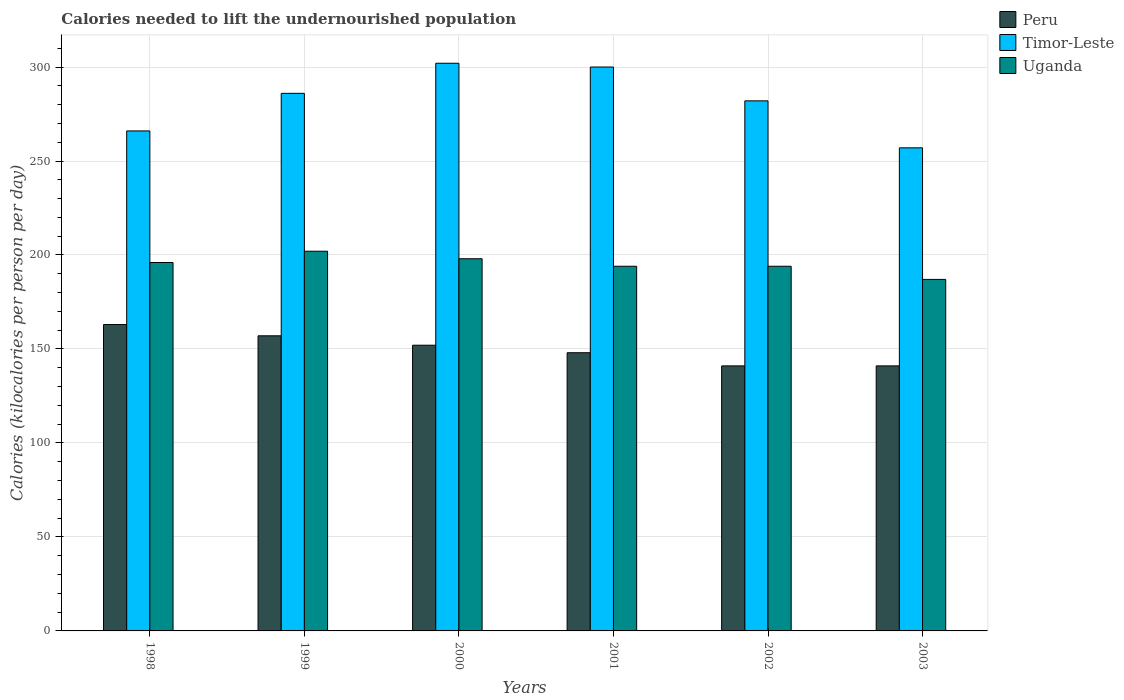Are the number of bars on each tick of the X-axis equal?
Offer a very short reply. Yes. How many bars are there on the 2nd tick from the left?
Ensure brevity in your answer.  3. How many bars are there on the 6th tick from the right?
Your response must be concise. 3. In how many cases, is the number of bars for a given year not equal to the number of legend labels?
Provide a short and direct response. 0. What is the total calories needed to lift the undernourished population in Uganda in 1998?
Make the answer very short. 196. Across all years, what is the maximum total calories needed to lift the undernourished population in Peru?
Offer a very short reply. 163. Across all years, what is the minimum total calories needed to lift the undernourished population in Uganda?
Provide a succinct answer. 187. In which year was the total calories needed to lift the undernourished population in Uganda maximum?
Give a very brief answer. 1999. In which year was the total calories needed to lift the undernourished population in Timor-Leste minimum?
Your answer should be very brief. 2003. What is the total total calories needed to lift the undernourished population in Timor-Leste in the graph?
Ensure brevity in your answer.  1693. What is the difference between the total calories needed to lift the undernourished population in Uganda in 2000 and that in 2003?
Your answer should be very brief. 11. What is the difference between the total calories needed to lift the undernourished population in Peru in 2003 and the total calories needed to lift the undernourished population in Timor-Leste in 2001?
Provide a succinct answer. -159. What is the average total calories needed to lift the undernourished population in Timor-Leste per year?
Your answer should be compact. 282.17. In the year 2002, what is the difference between the total calories needed to lift the undernourished population in Uganda and total calories needed to lift the undernourished population in Timor-Leste?
Your answer should be very brief. -88. In how many years, is the total calories needed to lift the undernourished population in Uganda greater than 20 kilocalories?
Give a very brief answer. 6. What is the ratio of the total calories needed to lift the undernourished population in Timor-Leste in 1999 to that in 2001?
Your response must be concise. 0.95. What is the difference between the highest and the lowest total calories needed to lift the undernourished population in Uganda?
Your answer should be compact. 15. What does the 2nd bar from the left in 1998 represents?
Your answer should be compact. Timor-Leste. How many bars are there?
Offer a very short reply. 18. What is the difference between two consecutive major ticks on the Y-axis?
Give a very brief answer. 50. Does the graph contain any zero values?
Give a very brief answer. No. Does the graph contain grids?
Keep it short and to the point. Yes. How many legend labels are there?
Keep it short and to the point. 3. What is the title of the graph?
Your answer should be compact. Calories needed to lift the undernourished population. What is the label or title of the Y-axis?
Make the answer very short. Calories (kilocalories per person per day). What is the Calories (kilocalories per person per day) in Peru in 1998?
Keep it short and to the point. 163. What is the Calories (kilocalories per person per day) in Timor-Leste in 1998?
Offer a very short reply. 266. What is the Calories (kilocalories per person per day) of Uganda in 1998?
Your response must be concise. 196. What is the Calories (kilocalories per person per day) of Peru in 1999?
Your answer should be compact. 157. What is the Calories (kilocalories per person per day) of Timor-Leste in 1999?
Give a very brief answer. 286. What is the Calories (kilocalories per person per day) of Uganda in 1999?
Make the answer very short. 202. What is the Calories (kilocalories per person per day) in Peru in 2000?
Provide a succinct answer. 152. What is the Calories (kilocalories per person per day) in Timor-Leste in 2000?
Offer a very short reply. 302. What is the Calories (kilocalories per person per day) of Uganda in 2000?
Ensure brevity in your answer.  198. What is the Calories (kilocalories per person per day) in Peru in 2001?
Offer a very short reply. 148. What is the Calories (kilocalories per person per day) in Timor-Leste in 2001?
Provide a short and direct response. 300. What is the Calories (kilocalories per person per day) of Uganda in 2001?
Provide a succinct answer. 194. What is the Calories (kilocalories per person per day) of Peru in 2002?
Provide a short and direct response. 141. What is the Calories (kilocalories per person per day) in Timor-Leste in 2002?
Keep it short and to the point. 282. What is the Calories (kilocalories per person per day) in Uganda in 2002?
Keep it short and to the point. 194. What is the Calories (kilocalories per person per day) in Peru in 2003?
Make the answer very short. 141. What is the Calories (kilocalories per person per day) of Timor-Leste in 2003?
Offer a terse response. 257. What is the Calories (kilocalories per person per day) of Uganda in 2003?
Offer a terse response. 187. Across all years, what is the maximum Calories (kilocalories per person per day) in Peru?
Offer a terse response. 163. Across all years, what is the maximum Calories (kilocalories per person per day) in Timor-Leste?
Make the answer very short. 302. Across all years, what is the maximum Calories (kilocalories per person per day) of Uganda?
Offer a very short reply. 202. Across all years, what is the minimum Calories (kilocalories per person per day) in Peru?
Ensure brevity in your answer.  141. Across all years, what is the minimum Calories (kilocalories per person per day) of Timor-Leste?
Your answer should be compact. 257. Across all years, what is the minimum Calories (kilocalories per person per day) of Uganda?
Provide a succinct answer. 187. What is the total Calories (kilocalories per person per day) in Peru in the graph?
Keep it short and to the point. 902. What is the total Calories (kilocalories per person per day) in Timor-Leste in the graph?
Provide a short and direct response. 1693. What is the total Calories (kilocalories per person per day) of Uganda in the graph?
Keep it short and to the point. 1171. What is the difference between the Calories (kilocalories per person per day) of Peru in 1998 and that in 1999?
Offer a very short reply. 6. What is the difference between the Calories (kilocalories per person per day) in Uganda in 1998 and that in 1999?
Offer a terse response. -6. What is the difference between the Calories (kilocalories per person per day) in Peru in 1998 and that in 2000?
Keep it short and to the point. 11. What is the difference between the Calories (kilocalories per person per day) of Timor-Leste in 1998 and that in 2000?
Offer a very short reply. -36. What is the difference between the Calories (kilocalories per person per day) in Timor-Leste in 1998 and that in 2001?
Your answer should be compact. -34. What is the difference between the Calories (kilocalories per person per day) in Uganda in 1998 and that in 2001?
Keep it short and to the point. 2. What is the difference between the Calories (kilocalories per person per day) of Uganda in 1998 and that in 2002?
Your answer should be very brief. 2. What is the difference between the Calories (kilocalories per person per day) of Timor-Leste in 1998 and that in 2003?
Provide a succinct answer. 9. What is the difference between the Calories (kilocalories per person per day) in Peru in 1999 and that in 2000?
Give a very brief answer. 5. What is the difference between the Calories (kilocalories per person per day) in Timor-Leste in 1999 and that in 2000?
Offer a very short reply. -16. What is the difference between the Calories (kilocalories per person per day) in Uganda in 1999 and that in 2000?
Your response must be concise. 4. What is the difference between the Calories (kilocalories per person per day) in Peru in 1999 and that in 2001?
Your response must be concise. 9. What is the difference between the Calories (kilocalories per person per day) of Timor-Leste in 1999 and that in 2001?
Provide a succinct answer. -14. What is the difference between the Calories (kilocalories per person per day) in Uganda in 1999 and that in 2001?
Offer a terse response. 8. What is the difference between the Calories (kilocalories per person per day) of Peru in 1999 and that in 2002?
Provide a short and direct response. 16. What is the difference between the Calories (kilocalories per person per day) in Timor-Leste in 1999 and that in 2002?
Give a very brief answer. 4. What is the difference between the Calories (kilocalories per person per day) in Timor-Leste in 1999 and that in 2003?
Make the answer very short. 29. What is the difference between the Calories (kilocalories per person per day) in Uganda in 1999 and that in 2003?
Offer a terse response. 15. What is the difference between the Calories (kilocalories per person per day) of Timor-Leste in 2000 and that in 2001?
Ensure brevity in your answer.  2. What is the difference between the Calories (kilocalories per person per day) in Uganda in 2000 and that in 2001?
Ensure brevity in your answer.  4. What is the difference between the Calories (kilocalories per person per day) of Peru in 2000 and that in 2002?
Your response must be concise. 11. What is the difference between the Calories (kilocalories per person per day) of Timor-Leste in 2000 and that in 2003?
Your answer should be very brief. 45. What is the difference between the Calories (kilocalories per person per day) in Peru in 2001 and that in 2002?
Your answer should be compact. 7. What is the difference between the Calories (kilocalories per person per day) of Timor-Leste in 2001 and that in 2002?
Your answer should be very brief. 18. What is the difference between the Calories (kilocalories per person per day) in Uganda in 2001 and that in 2002?
Make the answer very short. 0. What is the difference between the Calories (kilocalories per person per day) in Timor-Leste in 2001 and that in 2003?
Offer a very short reply. 43. What is the difference between the Calories (kilocalories per person per day) in Uganda in 2001 and that in 2003?
Ensure brevity in your answer.  7. What is the difference between the Calories (kilocalories per person per day) of Peru in 1998 and the Calories (kilocalories per person per day) of Timor-Leste in 1999?
Give a very brief answer. -123. What is the difference between the Calories (kilocalories per person per day) in Peru in 1998 and the Calories (kilocalories per person per day) in Uganda in 1999?
Give a very brief answer. -39. What is the difference between the Calories (kilocalories per person per day) in Timor-Leste in 1998 and the Calories (kilocalories per person per day) in Uganda in 1999?
Provide a short and direct response. 64. What is the difference between the Calories (kilocalories per person per day) in Peru in 1998 and the Calories (kilocalories per person per day) in Timor-Leste in 2000?
Keep it short and to the point. -139. What is the difference between the Calories (kilocalories per person per day) of Peru in 1998 and the Calories (kilocalories per person per day) of Uganda in 2000?
Offer a terse response. -35. What is the difference between the Calories (kilocalories per person per day) of Peru in 1998 and the Calories (kilocalories per person per day) of Timor-Leste in 2001?
Ensure brevity in your answer.  -137. What is the difference between the Calories (kilocalories per person per day) of Peru in 1998 and the Calories (kilocalories per person per day) of Uganda in 2001?
Provide a succinct answer. -31. What is the difference between the Calories (kilocalories per person per day) in Timor-Leste in 1998 and the Calories (kilocalories per person per day) in Uganda in 2001?
Keep it short and to the point. 72. What is the difference between the Calories (kilocalories per person per day) in Peru in 1998 and the Calories (kilocalories per person per day) in Timor-Leste in 2002?
Make the answer very short. -119. What is the difference between the Calories (kilocalories per person per day) of Peru in 1998 and the Calories (kilocalories per person per day) of Uganda in 2002?
Offer a very short reply. -31. What is the difference between the Calories (kilocalories per person per day) in Timor-Leste in 1998 and the Calories (kilocalories per person per day) in Uganda in 2002?
Provide a succinct answer. 72. What is the difference between the Calories (kilocalories per person per day) of Peru in 1998 and the Calories (kilocalories per person per day) of Timor-Leste in 2003?
Ensure brevity in your answer.  -94. What is the difference between the Calories (kilocalories per person per day) of Timor-Leste in 1998 and the Calories (kilocalories per person per day) of Uganda in 2003?
Provide a succinct answer. 79. What is the difference between the Calories (kilocalories per person per day) in Peru in 1999 and the Calories (kilocalories per person per day) in Timor-Leste in 2000?
Your answer should be very brief. -145. What is the difference between the Calories (kilocalories per person per day) in Peru in 1999 and the Calories (kilocalories per person per day) in Uganda in 2000?
Make the answer very short. -41. What is the difference between the Calories (kilocalories per person per day) of Peru in 1999 and the Calories (kilocalories per person per day) of Timor-Leste in 2001?
Provide a short and direct response. -143. What is the difference between the Calories (kilocalories per person per day) in Peru in 1999 and the Calories (kilocalories per person per day) in Uganda in 2001?
Your answer should be compact. -37. What is the difference between the Calories (kilocalories per person per day) of Timor-Leste in 1999 and the Calories (kilocalories per person per day) of Uganda in 2001?
Give a very brief answer. 92. What is the difference between the Calories (kilocalories per person per day) of Peru in 1999 and the Calories (kilocalories per person per day) of Timor-Leste in 2002?
Provide a short and direct response. -125. What is the difference between the Calories (kilocalories per person per day) in Peru in 1999 and the Calories (kilocalories per person per day) in Uganda in 2002?
Give a very brief answer. -37. What is the difference between the Calories (kilocalories per person per day) in Timor-Leste in 1999 and the Calories (kilocalories per person per day) in Uganda in 2002?
Your answer should be very brief. 92. What is the difference between the Calories (kilocalories per person per day) of Peru in 1999 and the Calories (kilocalories per person per day) of Timor-Leste in 2003?
Your answer should be very brief. -100. What is the difference between the Calories (kilocalories per person per day) in Peru in 1999 and the Calories (kilocalories per person per day) in Uganda in 2003?
Give a very brief answer. -30. What is the difference between the Calories (kilocalories per person per day) in Timor-Leste in 1999 and the Calories (kilocalories per person per day) in Uganda in 2003?
Ensure brevity in your answer.  99. What is the difference between the Calories (kilocalories per person per day) of Peru in 2000 and the Calories (kilocalories per person per day) of Timor-Leste in 2001?
Ensure brevity in your answer.  -148. What is the difference between the Calories (kilocalories per person per day) in Peru in 2000 and the Calories (kilocalories per person per day) in Uganda in 2001?
Keep it short and to the point. -42. What is the difference between the Calories (kilocalories per person per day) of Timor-Leste in 2000 and the Calories (kilocalories per person per day) of Uganda in 2001?
Your response must be concise. 108. What is the difference between the Calories (kilocalories per person per day) in Peru in 2000 and the Calories (kilocalories per person per day) in Timor-Leste in 2002?
Offer a terse response. -130. What is the difference between the Calories (kilocalories per person per day) in Peru in 2000 and the Calories (kilocalories per person per day) in Uganda in 2002?
Provide a short and direct response. -42. What is the difference between the Calories (kilocalories per person per day) of Timor-Leste in 2000 and the Calories (kilocalories per person per day) of Uganda in 2002?
Make the answer very short. 108. What is the difference between the Calories (kilocalories per person per day) in Peru in 2000 and the Calories (kilocalories per person per day) in Timor-Leste in 2003?
Give a very brief answer. -105. What is the difference between the Calories (kilocalories per person per day) in Peru in 2000 and the Calories (kilocalories per person per day) in Uganda in 2003?
Provide a succinct answer. -35. What is the difference between the Calories (kilocalories per person per day) of Timor-Leste in 2000 and the Calories (kilocalories per person per day) of Uganda in 2003?
Make the answer very short. 115. What is the difference between the Calories (kilocalories per person per day) of Peru in 2001 and the Calories (kilocalories per person per day) of Timor-Leste in 2002?
Your answer should be very brief. -134. What is the difference between the Calories (kilocalories per person per day) of Peru in 2001 and the Calories (kilocalories per person per day) of Uganda in 2002?
Your answer should be compact. -46. What is the difference between the Calories (kilocalories per person per day) of Timor-Leste in 2001 and the Calories (kilocalories per person per day) of Uganda in 2002?
Keep it short and to the point. 106. What is the difference between the Calories (kilocalories per person per day) of Peru in 2001 and the Calories (kilocalories per person per day) of Timor-Leste in 2003?
Ensure brevity in your answer.  -109. What is the difference between the Calories (kilocalories per person per day) in Peru in 2001 and the Calories (kilocalories per person per day) in Uganda in 2003?
Make the answer very short. -39. What is the difference between the Calories (kilocalories per person per day) in Timor-Leste in 2001 and the Calories (kilocalories per person per day) in Uganda in 2003?
Ensure brevity in your answer.  113. What is the difference between the Calories (kilocalories per person per day) in Peru in 2002 and the Calories (kilocalories per person per day) in Timor-Leste in 2003?
Give a very brief answer. -116. What is the difference between the Calories (kilocalories per person per day) in Peru in 2002 and the Calories (kilocalories per person per day) in Uganda in 2003?
Your answer should be very brief. -46. What is the average Calories (kilocalories per person per day) in Peru per year?
Offer a very short reply. 150.33. What is the average Calories (kilocalories per person per day) of Timor-Leste per year?
Provide a short and direct response. 282.17. What is the average Calories (kilocalories per person per day) of Uganda per year?
Ensure brevity in your answer.  195.17. In the year 1998, what is the difference between the Calories (kilocalories per person per day) in Peru and Calories (kilocalories per person per day) in Timor-Leste?
Your response must be concise. -103. In the year 1998, what is the difference between the Calories (kilocalories per person per day) in Peru and Calories (kilocalories per person per day) in Uganda?
Provide a short and direct response. -33. In the year 1998, what is the difference between the Calories (kilocalories per person per day) in Timor-Leste and Calories (kilocalories per person per day) in Uganda?
Offer a terse response. 70. In the year 1999, what is the difference between the Calories (kilocalories per person per day) of Peru and Calories (kilocalories per person per day) of Timor-Leste?
Keep it short and to the point. -129. In the year 1999, what is the difference between the Calories (kilocalories per person per day) of Peru and Calories (kilocalories per person per day) of Uganda?
Ensure brevity in your answer.  -45. In the year 2000, what is the difference between the Calories (kilocalories per person per day) in Peru and Calories (kilocalories per person per day) in Timor-Leste?
Keep it short and to the point. -150. In the year 2000, what is the difference between the Calories (kilocalories per person per day) in Peru and Calories (kilocalories per person per day) in Uganda?
Give a very brief answer. -46. In the year 2000, what is the difference between the Calories (kilocalories per person per day) in Timor-Leste and Calories (kilocalories per person per day) in Uganda?
Make the answer very short. 104. In the year 2001, what is the difference between the Calories (kilocalories per person per day) in Peru and Calories (kilocalories per person per day) in Timor-Leste?
Provide a short and direct response. -152. In the year 2001, what is the difference between the Calories (kilocalories per person per day) of Peru and Calories (kilocalories per person per day) of Uganda?
Provide a succinct answer. -46. In the year 2001, what is the difference between the Calories (kilocalories per person per day) of Timor-Leste and Calories (kilocalories per person per day) of Uganda?
Offer a terse response. 106. In the year 2002, what is the difference between the Calories (kilocalories per person per day) in Peru and Calories (kilocalories per person per day) in Timor-Leste?
Make the answer very short. -141. In the year 2002, what is the difference between the Calories (kilocalories per person per day) of Peru and Calories (kilocalories per person per day) of Uganda?
Your answer should be very brief. -53. In the year 2003, what is the difference between the Calories (kilocalories per person per day) of Peru and Calories (kilocalories per person per day) of Timor-Leste?
Keep it short and to the point. -116. In the year 2003, what is the difference between the Calories (kilocalories per person per day) in Peru and Calories (kilocalories per person per day) in Uganda?
Make the answer very short. -46. In the year 2003, what is the difference between the Calories (kilocalories per person per day) of Timor-Leste and Calories (kilocalories per person per day) of Uganda?
Your answer should be compact. 70. What is the ratio of the Calories (kilocalories per person per day) in Peru in 1998 to that in 1999?
Offer a terse response. 1.04. What is the ratio of the Calories (kilocalories per person per day) in Timor-Leste in 1998 to that in 1999?
Provide a succinct answer. 0.93. What is the ratio of the Calories (kilocalories per person per day) of Uganda in 1998 to that in 1999?
Provide a short and direct response. 0.97. What is the ratio of the Calories (kilocalories per person per day) in Peru in 1998 to that in 2000?
Offer a terse response. 1.07. What is the ratio of the Calories (kilocalories per person per day) of Timor-Leste in 1998 to that in 2000?
Ensure brevity in your answer.  0.88. What is the ratio of the Calories (kilocalories per person per day) in Uganda in 1998 to that in 2000?
Ensure brevity in your answer.  0.99. What is the ratio of the Calories (kilocalories per person per day) of Peru in 1998 to that in 2001?
Offer a very short reply. 1.1. What is the ratio of the Calories (kilocalories per person per day) of Timor-Leste in 1998 to that in 2001?
Your answer should be compact. 0.89. What is the ratio of the Calories (kilocalories per person per day) in Uganda in 1998 to that in 2001?
Keep it short and to the point. 1.01. What is the ratio of the Calories (kilocalories per person per day) of Peru in 1998 to that in 2002?
Your answer should be compact. 1.16. What is the ratio of the Calories (kilocalories per person per day) of Timor-Leste in 1998 to that in 2002?
Your answer should be very brief. 0.94. What is the ratio of the Calories (kilocalories per person per day) in Uganda in 1998 to that in 2002?
Give a very brief answer. 1.01. What is the ratio of the Calories (kilocalories per person per day) in Peru in 1998 to that in 2003?
Ensure brevity in your answer.  1.16. What is the ratio of the Calories (kilocalories per person per day) in Timor-Leste in 1998 to that in 2003?
Make the answer very short. 1.03. What is the ratio of the Calories (kilocalories per person per day) in Uganda in 1998 to that in 2003?
Keep it short and to the point. 1.05. What is the ratio of the Calories (kilocalories per person per day) in Peru in 1999 to that in 2000?
Offer a very short reply. 1.03. What is the ratio of the Calories (kilocalories per person per day) of Timor-Leste in 1999 to that in 2000?
Your answer should be compact. 0.95. What is the ratio of the Calories (kilocalories per person per day) of Uganda in 1999 to that in 2000?
Make the answer very short. 1.02. What is the ratio of the Calories (kilocalories per person per day) in Peru in 1999 to that in 2001?
Offer a very short reply. 1.06. What is the ratio of the Calories (kilocalories per person per day) in Timor-Leste in 1999 to that in 2001?
Ensure brevity in your answer.  0.95. What is the ratio of the Calories (kilocalories per person per day) in Uganda in 1999 to that in 2001?
Your answer should be compact. 1.04. What is the ratio of the Calories (kilocalories per person per day) of Peru in 1999 to that in 2002?
Give a very brief answer. 1.11. What is the ratio of the Calories (kilocalories per person per day) of Timor-Leste in 1999 to that in 2002?
Make the answer very short. 1.01. What is the ratio of the Calories (kilocalories per person per day) in Uganda in 1999 to that in 2002?
Provide a succinct answer. 1.04. What is the ratio of the Calories (kilocalories per person per day) in Peru in 1999 to that in 2003?
Ensure brevity in your answer.  1.11. What is the ratio of the Calories (kilocalories per person per day) in Timor-Leste in 1999 to that in 2003?
Keep it short and to the point. 1.11. What is the ratio of the Calories (kilocalories per person per day) of Uganda in 1999 to that in 2003?
Keep it short and to the point. 1.08. What is the ratio of the Calories (kilocalories per person per day) in Timor-Leste in 2000 to that in 2001?
Keep it short and to the point. 1.01. What is the ratio of the Calories (kilocalories per person per day) in Uganda in 2000 to that in 2001?
Give a very brief answer. 1.02. What is the ratio of the Calories (kilocalories per person per day) in Peru in 2000 to that in 2002?
Provide a succinct answer. 1.08. What is the ratio of the Calories (kilocalories per person per day) of Timor-Leste in 2000 to that in 2002?
Offer a terse response. 1.07. What is the ratio of the Calories (kilocalories per person per day) of Uganda in 2000 to that in 2002?
Your answer should be very brief. 1.02. What is the ratio of the Calories (kilocalories per person per day) in Peru in 2000 to that in 2003?
Offer a very short reply. 1.08. What is the ratio of the Calories (kilocalories per person per day) of Timor-Leste in 2000 to that in 2003?
Your answer should be compact. 1.18. What is the ratio of the Calories (kilocalories per person per day) of Uganda in 2000 to that in 2003?
Provide a short and direct response. 1.06. What is the ratio of the Calories (kilocalories per person per day) in Peru in 2001 to that in 2002?
Ensure brevity in your answer.  1.05. What is the ratio of the Calories (kilocalories per person per day) of Timor-Leste in 2001 to that in 2002?
Provide a short and direct response. 1.06. What is the ratio of the Calories (kilocalories per person per day) of Uganda in 2001 to that in 2002?
Your response must be concise. 1. What is the ratio of the Calories (kilocalories per person per day) in Peru in 2001 to that in 2003?
Ensure brevity in your answer.  1.05. What is the ratio of the Calories (kilocalories per person per day) of Timor-Leste in 2001 to that in 2003?
Provide a succinct answer. 1.17. What is the ratio of the Calories (kilocalories per person per day) of Uganda in 2001 to that in 2003?
Your response must be concise. 1.04. What is the ratio of the Calories (kilocalories per person per day) of Peru in 2002 to that in 2003?
Make the answer very short. 1. What is the ratio of the Calories (kilocalories per person per day) in Timor-Leste in 2002 to that in 2003?
Offer a very short reply. 1.1. What is the ratio of the Calories (kilocalories per person per day) in Uganda in 2002 to that in 2003?
Keep it short and to the point. 1.04. What is the difference between the highest and the second highest Calories (kilocalories per person per day) of Timor-Leste?
Your answer should be very brief. 2. What is the difference between the highest and the second highest Calories (kilocalories per person per day) in Uganda?
Ensure brevity in your answer.  4. What is the difference between the highest and the lowest Calories (kilocalories per person per day) of Timor-Leste?
Offer a terse response. 45. What is the difference between the highest and the lowest Calories (kilocalories per person per day) of Uganda?
Offer a very short reply. 15. 